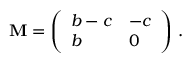Convert formula to latex. <formula><loc_0><loc_0><loc_500><loc_500>M = \left ( \begin{array} { l l } { b - c } & { - c } \\ { b } & { 0 } \end{array} \right ) \, .</formula> 